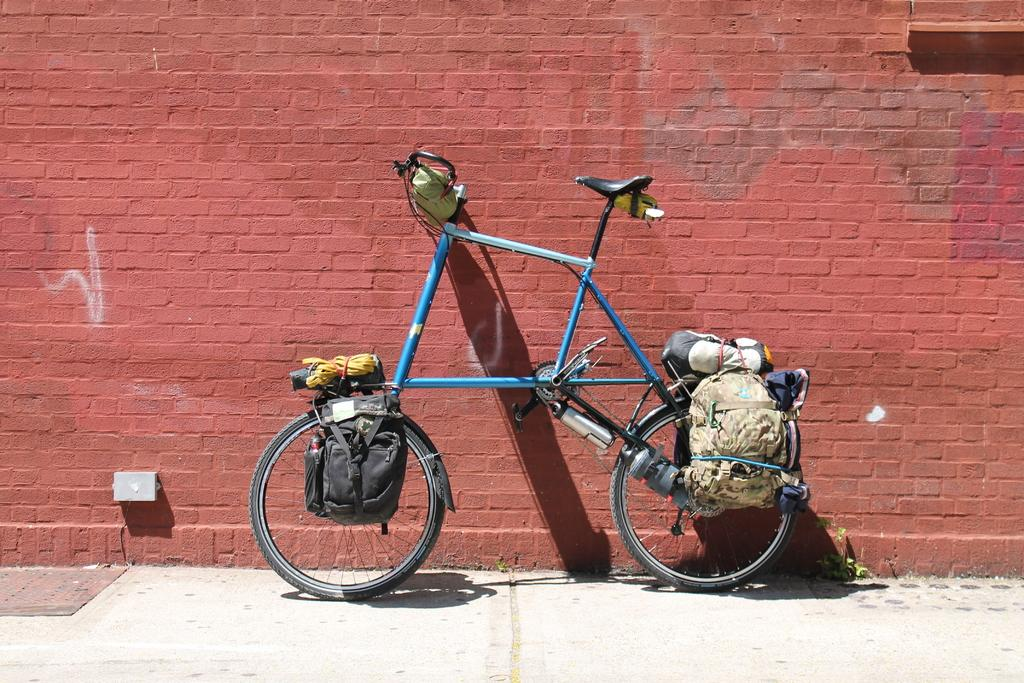What is the main object in the image? There is a bicycle in the image. What can be seen attached to the bicycle? The bicycle has bags and many objects on it. What colors are used for the bicycle? The bicycle is in blue and black color. What can be seen in the background of the image? There is a brown color brick wall in the background of the image. What type of treatment is being administered to the bike in the image? There is no treatment being administered to the bike in the image; it is simply a bicycle with bags and objects attached to it. 